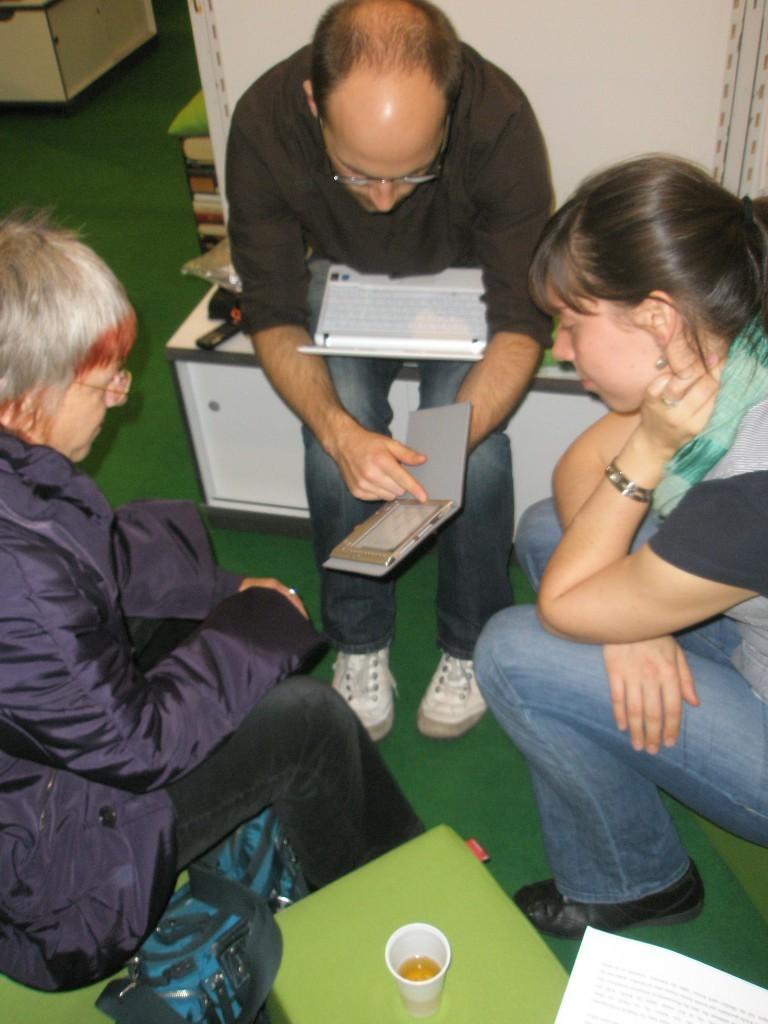Could you give a brief overview of what you see in this image? Here I can see three people are sitting and looking at the device which is in the hands of a man. At the bottom there is a table on which I can see a glass, paper and a bag. At the back of this man there is a wall. On the floor, I can see a green color mat. 